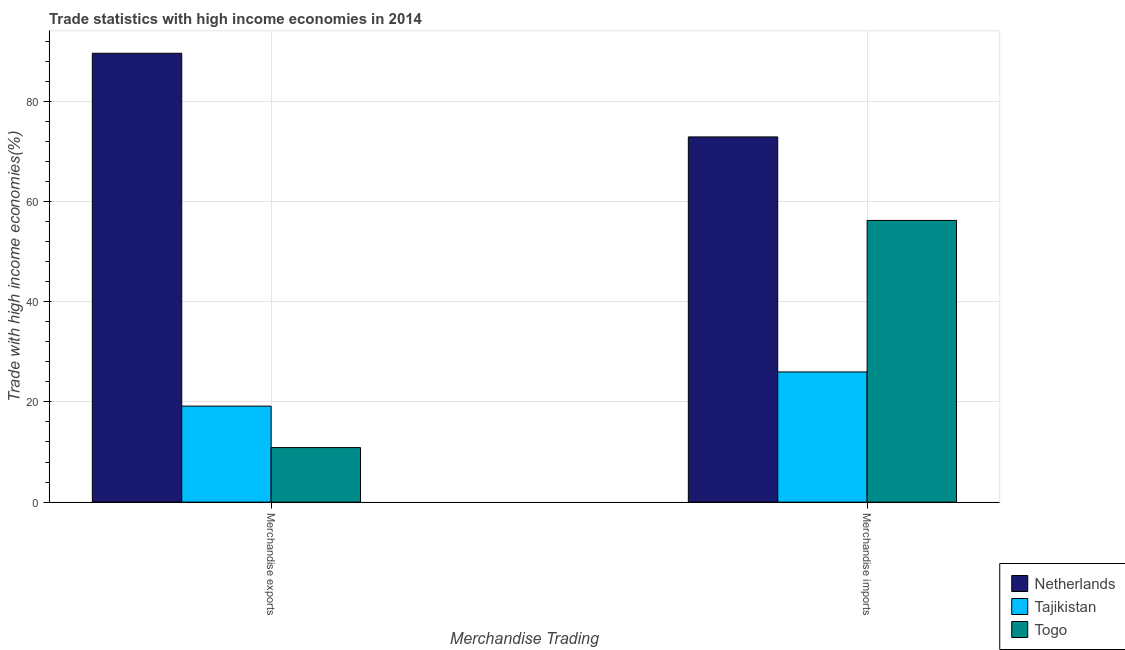How many bars are there on the 1st tick from the left?
Your answer should be very brief. 3. How many bars are there on the 1st tick from the right?
Offer a terse response. 3. What is the merchandise imports in Togo?
Your answer should be compact. 56.22. Across all countries, what is the maximum merchandise imports?
Your response must be concise. 72.88. Across all countries, what is the minimum merchandise imports?
Your response must be concise. 25.98. In which country was the merchandise imports maximum?
Make the answer very short. Netherlands. In which country was the merchandise imports minimum?
Ensure brevity in your answer.  Tajikistan. What is the total merchandise imports in the graph?
Keep it short and to the point. 155.08. What is the difference between the merchandise imports in Tajikistan and that in Togo?
Provide a succinct answer. -30.24. What is the difference between the merchandise imports in Netherlands and the merchandise exports in Tajikistan?
Ensure brevity in your answer.  53.72. What is the average merchandise imports per country?
Provide a short and direct response. 51.69. What is the difference between the merchandise exports and merchandise imports in Tajikistan?
Make the answer very short. -6.82. In how many countries, is the merchandise imports greater than 52 %?
Your answer should be compact. 2. What is the ratio of the merchandise exports in Tajikistan to that in Togo?
Give a very brief answer. 1.76. In how many countries, is the merchandise imports greater than the average merchandise imports taken over all countries?
Your answer should be very brief. 2. What does the 2nd bar from the left in Merchandise exports represents?
Offer a terse response. Tajikistan. What does the 3rd bar from the right in Merchandise imports represents?
Provide a succinct answer. Netherlands. How many bars are there?
Offer a very short reply. 6. How many countries are there in the graph?
Provide a short and direct response. 3. What is the difference between two consecutive major ticks on the Y-axis?
Ensure brevity in your answer.  20. Are the values on the major ticks of Y-axis written in scientific E-notation?
Give a very brief answer. No. Does the graph contain any zero values?
Give a very brief answer. No. How are the legend labels stacked?
Offer a terse response. Vertical. What is the title of the graph?
Make the answer very short. Trade statistics with high income economies in 2014. What is the label or title of the X-axis?
Offer a terse response. Merchandise Trading. What is the label or title of the Y-axis?
Provide a succinct answer. Trade with high income economies(%). What is the Trade with high income economies(%) of Netherlands in Merchandise exports?
Your response must be concise. 89.57. What is the Trade with high income economies(%) of Tajikistan in Merchandise exports?
Offer a terse response. 19.16. What is the Trade with high income economies(%) of Togo in Merchandise exports?
Provide a succinct answer. 10.89. What is the Trade with high income economies(%) of Netherlands in Merchandise imports?
Provide a succinct answer. 72.88. What is the Trade with high income economies(%) in Tajikistan in Merchandise imports?
Your response must be concise. 25.98. What is the Trade with high income economies(%) of Togo in Merchandise imports?
Your response must be concise. 56.22. Across all Merchandise Trading, what is the maximum Trade with high income economies(%) in Netherlands?
Your answer should be compact. 89.57. Across all Merchandise Trading, what is the maximum Trade with high income economies(%) of Tajikistan?
Make the answer very short. 25.98. Across all Merchandise Trading, what is the maximum Trade with high income economies(%) in Togo?
Provide a succinct answer. 56.22. Across all Merchandise Trading, what is the minimum Trade with high income economies(%) in Netherlands?
Ensure brevity in your answer.  72.88. Across all Merchandise Trading, what is the minimum Trade with high income economies(%) of Tajikistan?
Your answer should be compact. 19.16. Across all Merchandise Trading, what is the minimum Trade with high income economies(%) of Togo?
Offer a terse response. 10.89. What is the total Trade with high income economies(%) of Netherlands in the graph?
Provide a short and direct response. 162.45. What is the total Trade with high income economies(%) in Tajikistan in the graph?
Your answer should be compact. 45.14. What is the total Trade with high income economies(%) in Togo in the graph?
Ensure brevity in your answer.  67.1. What is the difference between the Trade with high income economies(%) of Netherlands in Merchandise exports and that in Merchandise imports?
Provide a short and direct response. 16.69. What is the difference between the Trade with high income economies(%) of Tajikistan in Merchandise exports and that in Merchandise imports?
Keep it short and to the point. -6.82. What is the difference between the Trade with high income economies(%) in Togo in Merchandise exports and that in Merchandise imports?
Offer a very short reply. -45.33. What is the difference between the Trade with high income economies(%) in Netherlands in Merchandise exports and the Trade with high income economies(%) in Tajikistan in Merchandise imports?
Provide a succinct answer. 63.59. What is the difference between the Trade with high income economies(%) of Netherlands in Merchandise exports and the Trade with high income economies(%) of Togo in Merchandise imports?
Your answer should be very brief. 33.36. What is the difference between the Trade with high income economies(%) of Tajikistan in Merchandise exports and the Trade with high income economies(%) of Togo in Merchandise imports?
Provide a short and direct response. -37.06. What is the average Trade with high income economies(%) in Netherlands per Merchandise Trading?
Ensure brevity in your answer.  81.23. What is the average Trade with high income economies(%) of Tajikistan per Merchandise Trading?
Offer a terse response. 22.57. What is the average Trade with high income economies(%) of Togo per Merchandise Trading?
Your response must be concise. 33.55. What is the difference between the Trade with high income economies(%) of Netherlands and Trade with high income economies(%) of Tajikistan in Merchandise exports?
Ensure brevity in your answer.  70.42. What is the difference between the Trade with high income economies(%) of Netherlands and Trade with high income economies(%) of Togo in Merchandise exports?
Give a very brief answer. 78.69. What is the difference between the Trade with high income economies(%) in Tajikistan and Trade with high income economies(%) in Togo in Merchandise exports?
Make the answer very short. 8.27. What is the difference between the Trade with high income economies(%) of Netherlands and Trade with high income economies(%) of Tajikistan in Merchandise imports?
Provide a short and direct response. 46.9. What is the difference between the Trade with high income economies(%) of Netherlands and Trade with high income economies(%) of Togo in Merchandise imports?
Ensure brevity in your answer.  16.66. What is the difference between the Trade with high income economies(%) of Tajikistan and Trade with high income economies(%) of Togo in Merchandise imports?
Give a very brief answer. -30.24. What is the ratio of the Trade with high income economies(%) of Netherlands in Merchandise exports to that in Merchandise imports?
Your response must be concise. 1.23. What is the ratio of the Trade with high income economies(%) in Tajikistan in Merchandise exports to that in Merchandise imports?
Offer a very short reply. 0.74. What is the ratio of the Trade with high income economies(%) in Togo in Merchandise exports to that in Merchandise imports?
Ensure brevity in your answer.  0.19. What is the difference between the highest and the second highest Trade with high income economies(%) of Netherlands?
Give a very brief answer. 16.69. What is the difference between the highest and the second highest Trade with high income economies(%) of Tajikistan?
Provide a short and direct response. 6.82. What is the difference between the highest and the second highest Trade with high income economies(%) in Togo?
Your answer should be very brief. 45.33. What is the difference between the highest and the lowest Trade with high income economies(%) of Netherlands?
Keep it short and to the point. 16.69. What is the difference between the highest and the lowest Trade with high income economies(%) of Tajikistan?
Your response must be concise. 6.82. What is the difference between the highest and the lowest Trade with high income economies(%) in Togo?
Your answer should be compact. 45.33. 